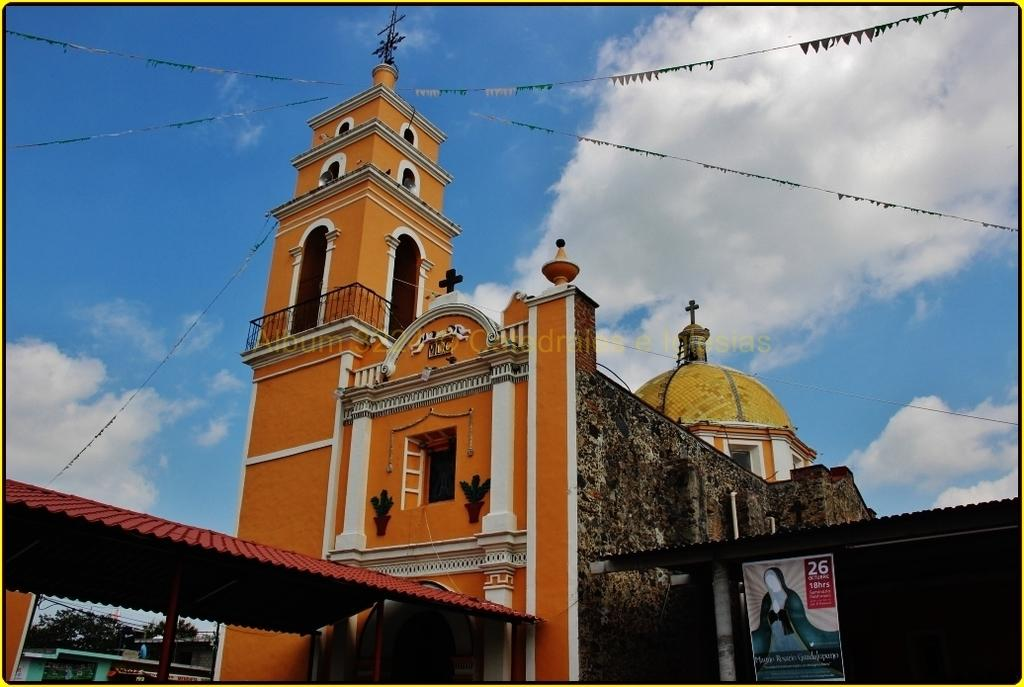What type of structures are visible in the image? There are buildings with windows in the image. What is hanging or displayed in the image? There is a banner in the image. What type of vegetation is present in the image? There are trees in the image. What part of the buildings can be accessed in the image? There is an open rooftop in the image. What other decorative elements are present in the image? There are flags in the image. What can be seen in the background of the image? The sky with clouds is visible in the background of the image. Can you see any smoke coming from the buildings in the image? There is no smoke visible in the image. Is there a cellar visible in the image? There is no mention of a cellar in the provided facts, and therefore it cannot be confirmed as present in the image. 